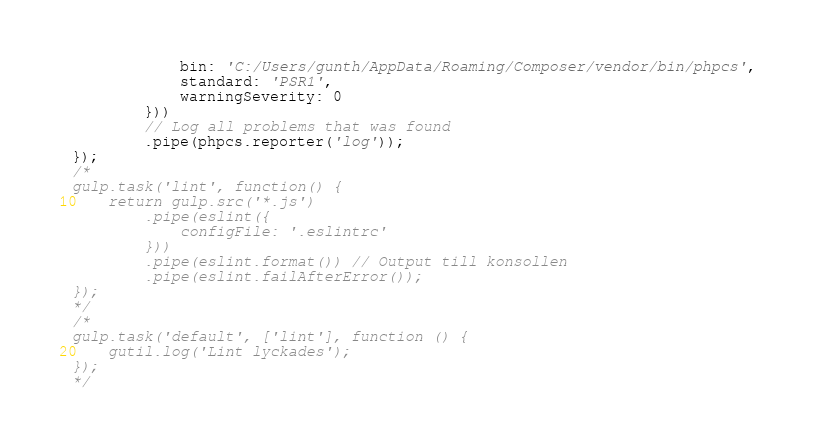<code> <loc_0><loc_0><loc_500><loc_500><_JavaScript_>            bin: 'C:/Users/gunth/AppData/Roaming/Composer/vendor/bin/phpcs',
            standard: 'PSR1',
            warningSeverity: 0
        }))
        // Log all problems that was found
        .pipe(phpcs.reporter('log'));
});
/*
gulp.task('lint', function() {
    return gulp.src('*.js')
        .pipe(eslint({
            configFile: '.eslintrc'
        }))
        .pipe(eslint.format()) // Output till konsollen
        .pipe(eslint.failAfterError());
});
*/
/*
gulp.task('default', ['lint'], function () {
    gutil.log('Lint lyckades');
});
*/
</code> 